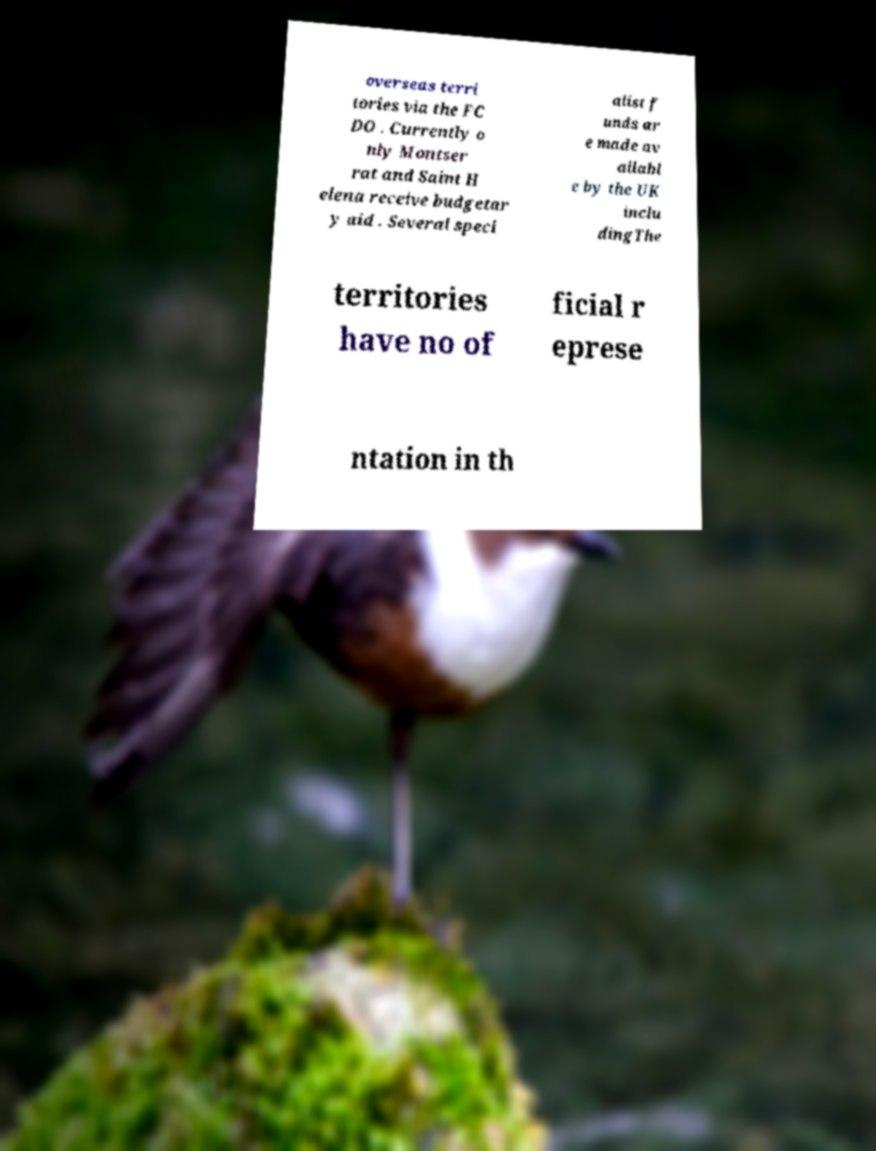Can you read and provide the text displayed in the image?This photo seems to have some interesting text. Can you extract and type it out for me? overseas terri tories via the FC DO . Currently o nly Montser rat and Saint H elena receive budgetar y aid . Several speci alist f unds ar e made av ailabl e by the UK inclu dingThe territories have no of ficial r eprese ntation in th 